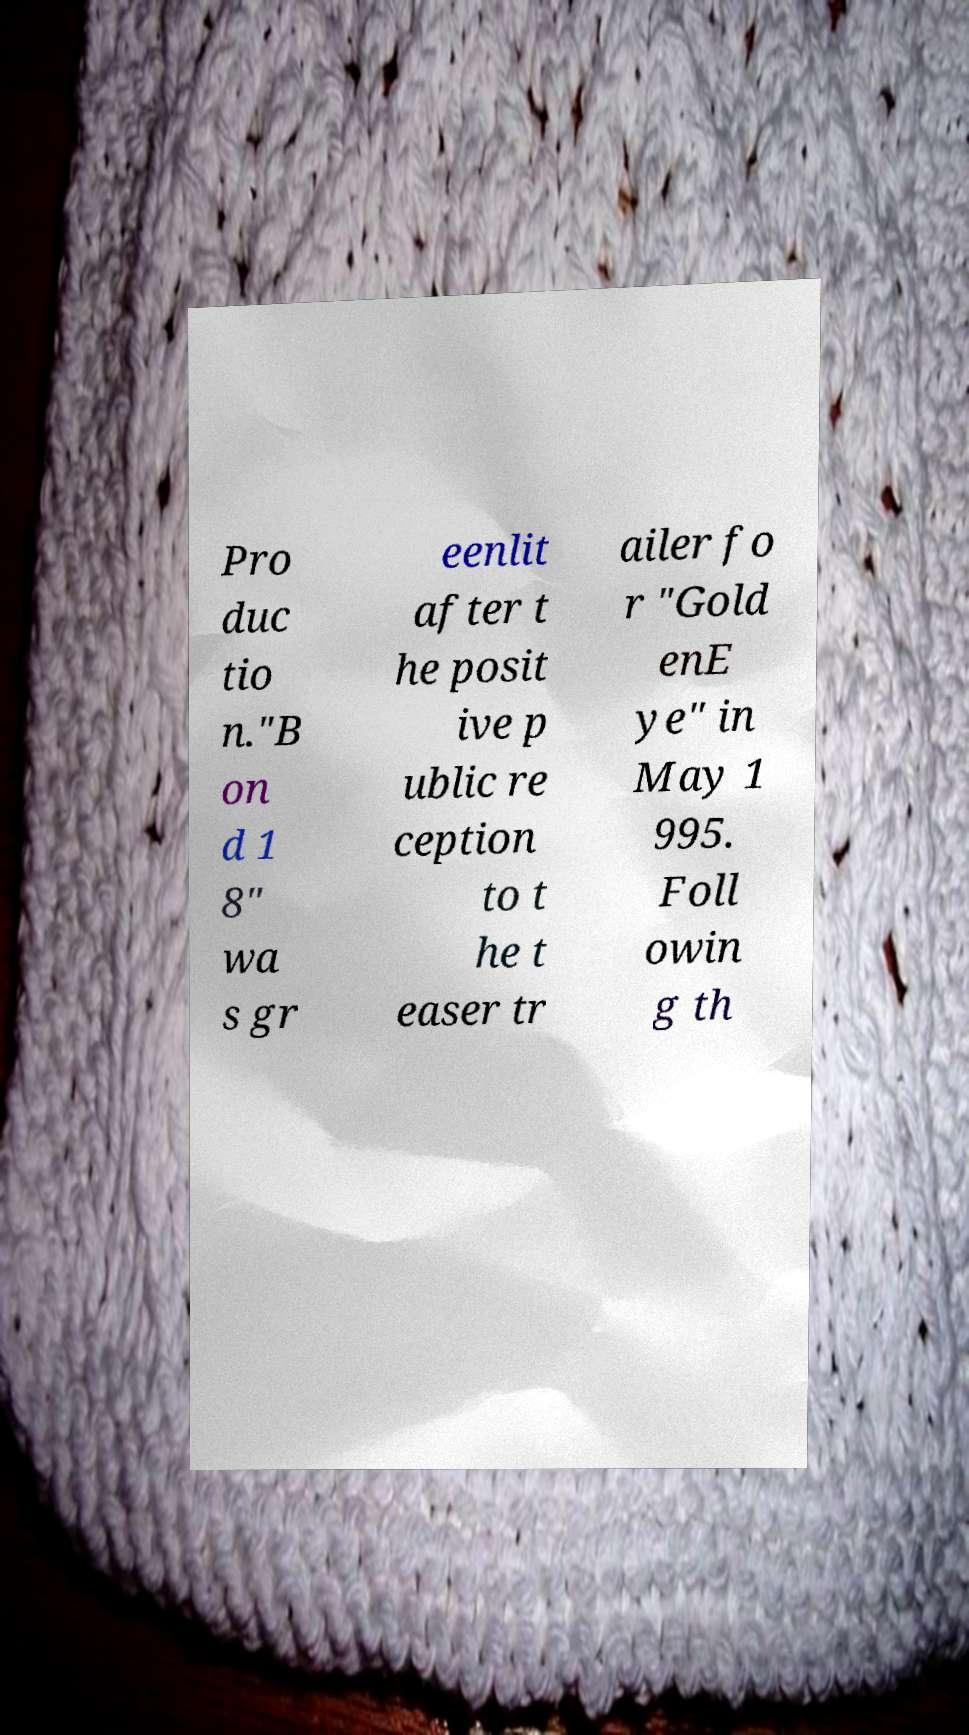Could you extract and type out the text from this image? Pro duc tio n."B on d 1 8" wa s gr eenlit after t he posit ive p ublic re ception to t he t easer tr ailer fo r "Gold enE ye" in May 1 995. Foll owin g th 